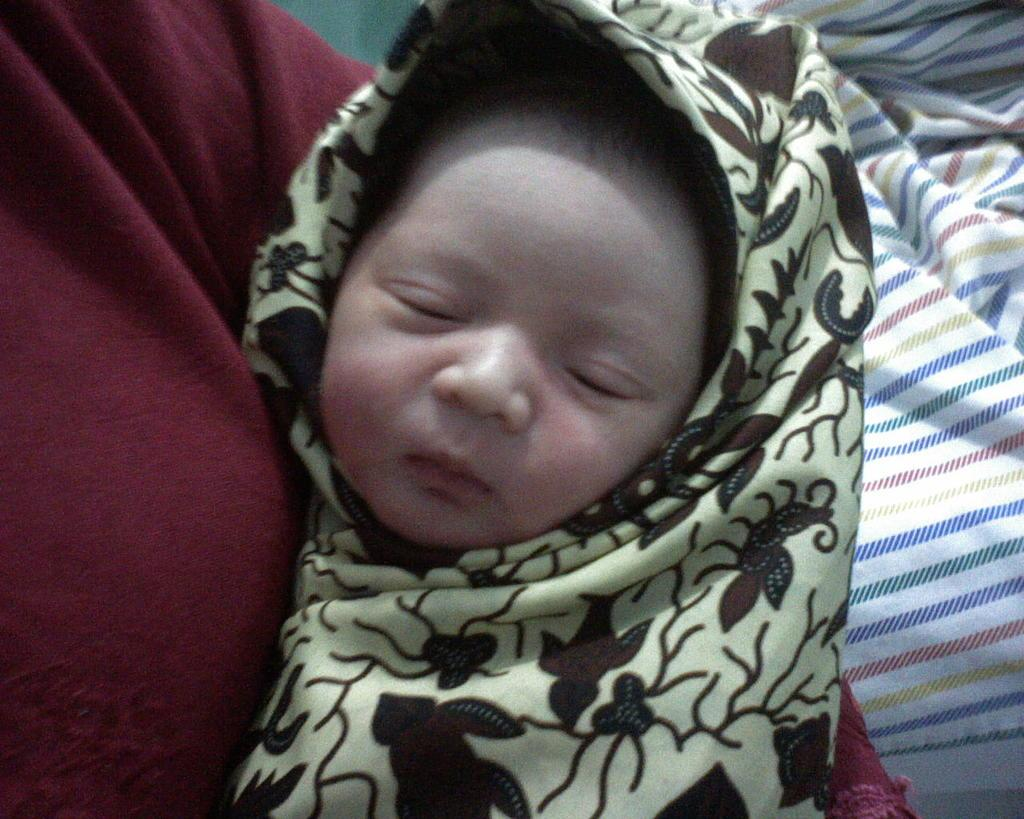Who is the main subject in the image? There is a woman in the image. What is the woman doing in the image? The woman is holding a baby. What can be seen in the background of the image? There is a blanket in the background of the image. Can you tell me how many kittens are playing with the baby in the image? There are no kittens present in the image; the woman is holding a baby. What type of pets can be seen interacting with the baby in the image? There are no pets present in the image; the woman is holding a baby. 